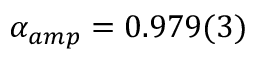<formula> <loc_0><loc_0><loc_500><loc_500>\alpha _ { a m p } = 0 . 9 7 9 ( 3 )</formula> 